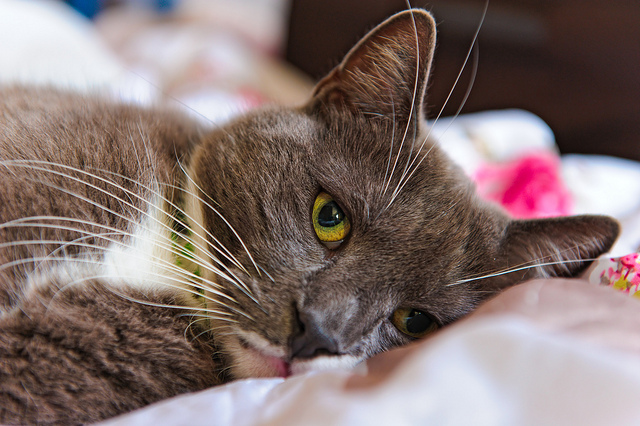Can you describe the setting in which the cat is lying? The cat is comfortably lying on a bed with cozy white sheets. The sheets look soft and inviting, making a perfect spot for a cat to relax. The background has a gentle blur, focusing on the cat's face, which expresses a calm yet slightly melancholic demeanor. This setting underscores a tranquil atmosphere, emphasizing the warmth and safety of the bed. What might the cat be thinking about while lying there? The cat might be thinking about its next meal, purring contentedly, or possibly recalling a recent playful moment. It could also be feeling a bit lonely, yearning for the company of its owner or fellow pets. Sometimes, cats simply enjoy the quiet, reflecting in their own feline way, savoring the comfort of the soft bed and the room’s calming ambiance. Imagine the cat goes on an adventure. Where does it go? In a whimsical adventure, the cat decides to explore the great outdoors. It slips out of the bedroom window and finds itself in a magical forest. The trees are tall and ancient, their leaves shimmering with an ethereal glow under the moonlight. As the cat ventures deeper, it encounters a group of talking animals, each with their own unique stories. Together, they embark on a journey to discover a hidden treasure said to grant any wish. Along the way, they face challenges that test their bravery and wit, reinforcing the bond of friendship formed during this enchanting endeavor. 